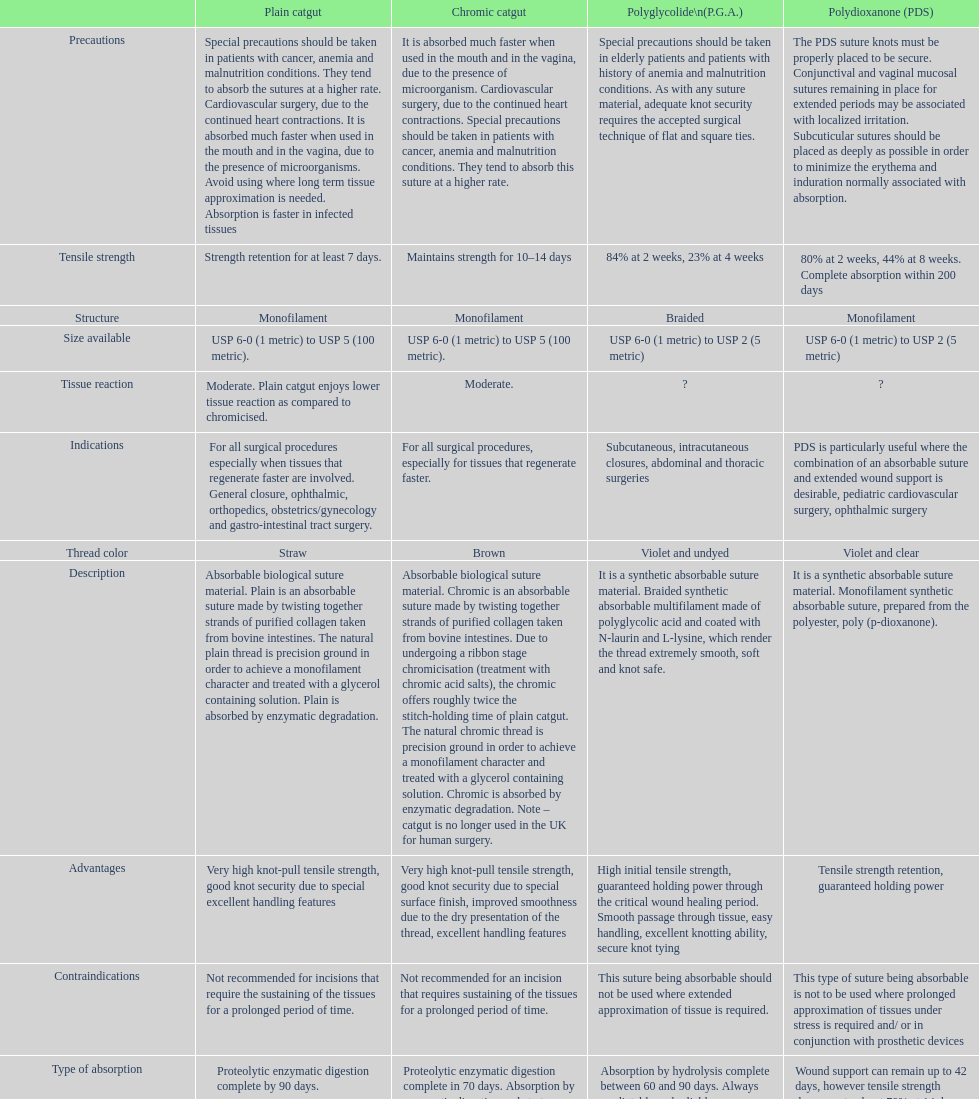What type of sutures are no longer used in the u.k. for human surgery? Chromic catgut. 